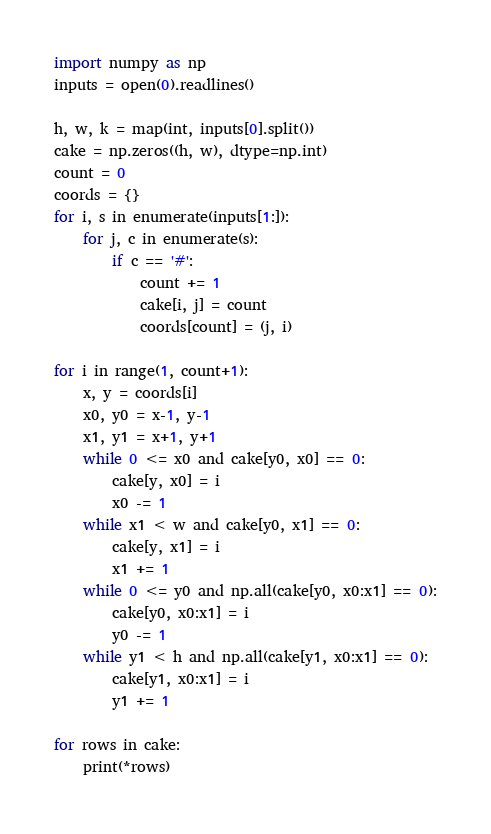Convert code to text. <code><loc_0><loc_0><loc_500><loc_500><_Python_>import numpy as np
inputs = open(0).readlines()

h, w, k = map(int, inputs[0].split())
cake = np.zeros((h, w), dtype=np.int)
count = 0
coords = {}
for i, s in enumerate(inputs[1:]):
    for j, c in enumerate(s):
        if c == '#':
            count += 1
            cake[i, j] = count
            coords[count] = (j, i)
            
for i in range(1, count+1):
    x, y = coords[i]
    x0, y0 = x-1, y-1
    x1, y1 = x+1, y+1
    while 0 <= x0 and cake[y0, x0] == 0:
        cake[y, x0] = i
        x0 -= 1
    while x1 < w and cake[y0, x1] == 0:
        cake[y, x1] = i
        x1 += 1
    while 0 <= y0 and np.all(cake[y0, x0:x1] == 0):
        cake[y0, x0:x1] = i
        y0 -= 1
    while y1 < h and np.all(cake[y1, x0:x1] == 0):
        cake[y1, x0:x1] = i
        y1 += 1

for rows in cake:
    print(*rows)</code> 